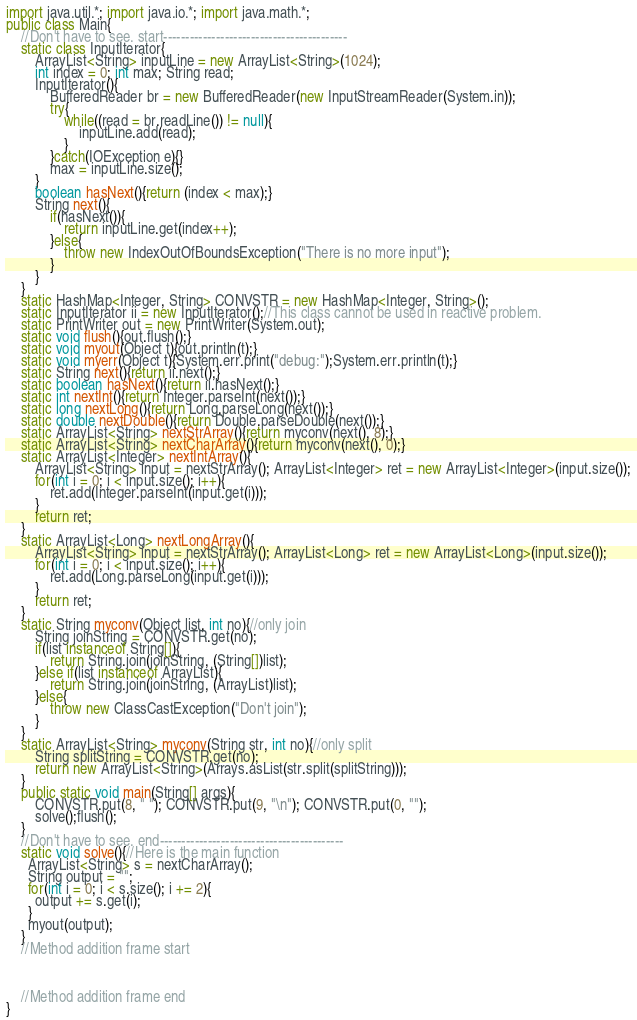Convert code to text. <code><loc_0><loc_0><loc_500><loc_500><_Java_>import java.util.*; import java.io.*; import java.math.*;
public class Main{
	//Don't have to see. start------------------------------------------
	static class InputIterator{
		ArrayList<String> inputLine = new ArrayList<String>(1024);
		int index = 0; int max; String read;
		InputIterator(){
			BufferedReader br = new BufferedReader(new InputStreamReader(System.in));
			try{
				while((read = br.readLine()) != null){
					inputLine.add(read);
				}
			}catch(IOException e){}
			max = inputLine.size();
		}
		boolean hasNext(){return (index < max);}
		String next(){
			if(hasNext()){
				return inputLine.get(index++);
			}else{
				throw new IndexOutOfBoundsException("There is no more input");
			}
		}
	}
	static HashMap<Integer, String> CONVSTR = new HashMap<Integer, String>();
	static InputIterator ii = new InputIterator();//This class cannot be used in reactive problem.
	static PrintWriter out = new PrintWriter(System.out);
	static void flush(){out.flush();}
	static void myout(Object t){out.println(t);}
	static void myerr(Object t){System.err.print("debug:");System.err.println(t);}
	static String next(){return ii.next();}
	static boolean hasNext(){return ii.hasNext();}
	static int nextInt(){return Integer.parseInt(next());}
	static long nextLong(){return Long.parseLong(next());}
	static double nextDouble(){return Double.parseDouble(next());}
	static ArrayList<String> nextStrArray(){return myconv(next(), 8);}
	static ArrayList<String> nextCharArray(){return myconv(next(), 0);}
	static ArrayList<Integer> nextIntArray(){
		ArrayList<String> input = nextStrArray(); ArrayList<Integer> ret = new ArrayList<Integer>(input.size());
		for(int i = 0; i < input.size(); i++){
			ret.add(Integer.parseInt(input.get(i)));
		}
		return ret;
	}
	static ArrayList<Long> nextLongArray(){
		ArrayList<String> input = nextStrArray(); ArrayList<Long> ret = new ArrayList<Long>(input.size());
		for(int i = 0; i < input.size(); i++){
			ret.add(Long.parseLong(input.get(i)));
		}
		return ret;
	}
	static String myconv(Object list, int no){//only join
		String joinString = CONVSTR.get(no);
		if(list instanceof String[]){
			return String.join(joinString, (String[])list);
		}else if(list instanceof ArrayList){
			return String.join(joinString, (ArrayList)list);
		}else{
			throw new ClassCastException("Don't join");
		}
	}
	static ArrayList<String> myconv(String str, int no){//only split
		String splitString = CONVSTR.get(no);
		return new ArrayList<String>(Arrays.asList(str.split(splitString)));
	}
	public static void main(String[] args){
		CONVSTR.put(8, " "); CONVSTR.put(9, "\n"); CONVSTR.put(0, "");
		solve();flush();
	}
	//Don't have to see. end------------------------------------------
	static void solve(){//Here is the main function
      ArrayList<String> s = nextCharArray();
      String output = "";
      for(int i = 0; i < s.size(); i += 2){
        output += s.get(i);
      }
      myout(output);
	}
	//Method addition frame start



	//Method addition frame end
}
</code> 